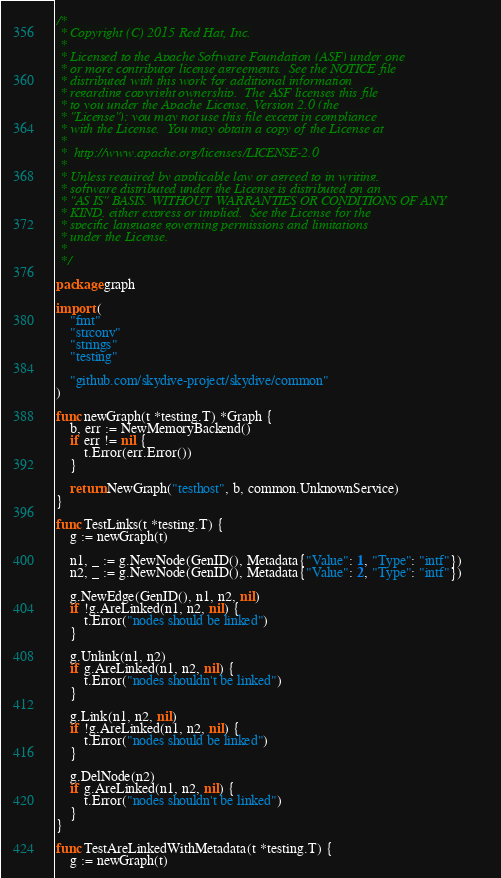<code> <loc_0><loc_0><loc_500><loc_500><_Go_>/*
 * Copyright (C) 2015 Red Hat, Inc.
 *
 * Licensed to the Apache Software Foundation (ASF) under one
 * or more contributor license agreements.  See the NOTICE file
 * distributed with this work for additional information
 * regarding copyright ownership.  The ASF licenses this file
 * to you under the Apache License, Version 2.0 (the
 * "License"); you may not use this file except in compliance
 * with the License.  You may obtain a copy of the License at
 *
 *  http://www.apache.org/licenses/LICENSE-2.0
 *
 * Unless required by applicable law or agreed to in writing,
 * software distributed under the License is distributed on an
 * "AS IS" BASIS, WITHOUT WARRANTIES OR CONDITIONS OF ANY
 * KIND, either express or implied.  See the License for the
 * specific language governing permissions and limitations
 * under the License.
 *
 */

package graph

import (
	"fmt"
	"strconv"
	"strings"
	"testing"

	"github.com/skydive-project/skydive/common"
)

func newGraph(t *testing.T) *Graph {
	b, err := NewMemoryBackend()
	if err != nil {
		t.Error(err.Error())
	}

	return NewGraph("testhost", b, common.UnknownService)
}

func TestLinks(t *testing.T) {
	g := newGraph(t)

	n1, _ := g.NewNode(GenID(), Metadata{"Value": 1, "Type": "intf"})
	n2, _ := g.NewNode(GenID(), Metadata{"Value": 2, "Type": "intf"})

	g.NewEdge(GenID(), n1, n2, nil)
	if !g.AreLinked(n1, n2, nil) {
		t.Error("nodes should be linked")
	}

	g.Unlink(n1, n2)
	if g.AreLinked(n1, n2, nil) {
		t.Error("nodes shouldn't be linked")
	}

	g.Link(n1, n2, nil)
	if !g.AreLinked(n1, n2, nil) {
		t.Error("nodes should be linked")
	}

	g.DelNode(n2)
	if g.AreLinked(n1, n2, nil) {
		t.Error("nodes shouldn't be linked")
	}
}

func TestAreLinkedWithMetadata(t *testing.T) {
	g := newGraph(t)
</code> 